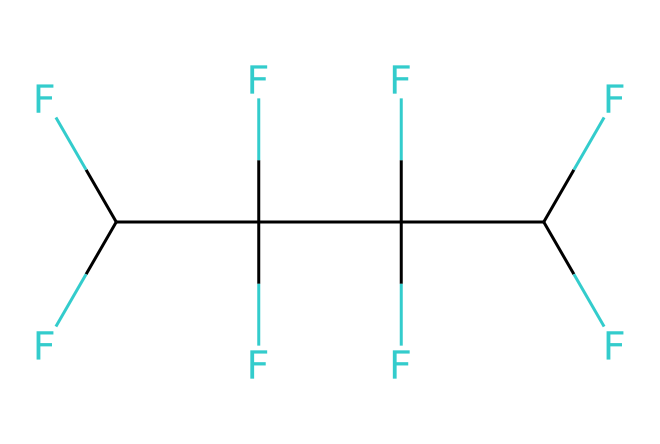How many carbon atoms are in this chemical structure? The SMILES representation indicates that there are four carbon atoms, as denoted by the four instances of 'C' in the beginning of the structure.
Answer: four What is the total number of fluorine atoms present in this compound? The structure shows that each carbon is bonded to three fluorine atoms, and with four carbon atoms, this results in a total of twelve fluorine atoms (4 carbons × 3 fluorines each).
Answer: twelve What type of chemical is PTFE commonly known as? PTFE is widely recognized as Teflon, which is a registered trademark name for the polymer.
Answer: Teflon What is the primary property of PTFE that makes it a good lubricant? PTFE is known for its low friction coefficient, which reduces the resistance when surfaces slide against each other.
Answer: low friction Why does PTFE have high chemical resistance? The presence of fluorine in PTFE contributes to its high chemical resistance due to the strong C-F bonds that do not easily react with other chemicals.
Answer: strong C-F bonds In the context of lubricants, what is a common application of PTFE? PTFE is commonly used in non-stick coatings for cookware, which allows for easy cooking and cleaning due to its non-reactive and slippery surface.
Answer: non-stick coatings What molecular feature in PTFE contributes to its hydrophobic nature? The fluorocarbon chains in PTFE create a hydrophobic surface because fluorine atoms repel water, preventing it from adhering to the surface.
Answer: fluorocarbon chains 